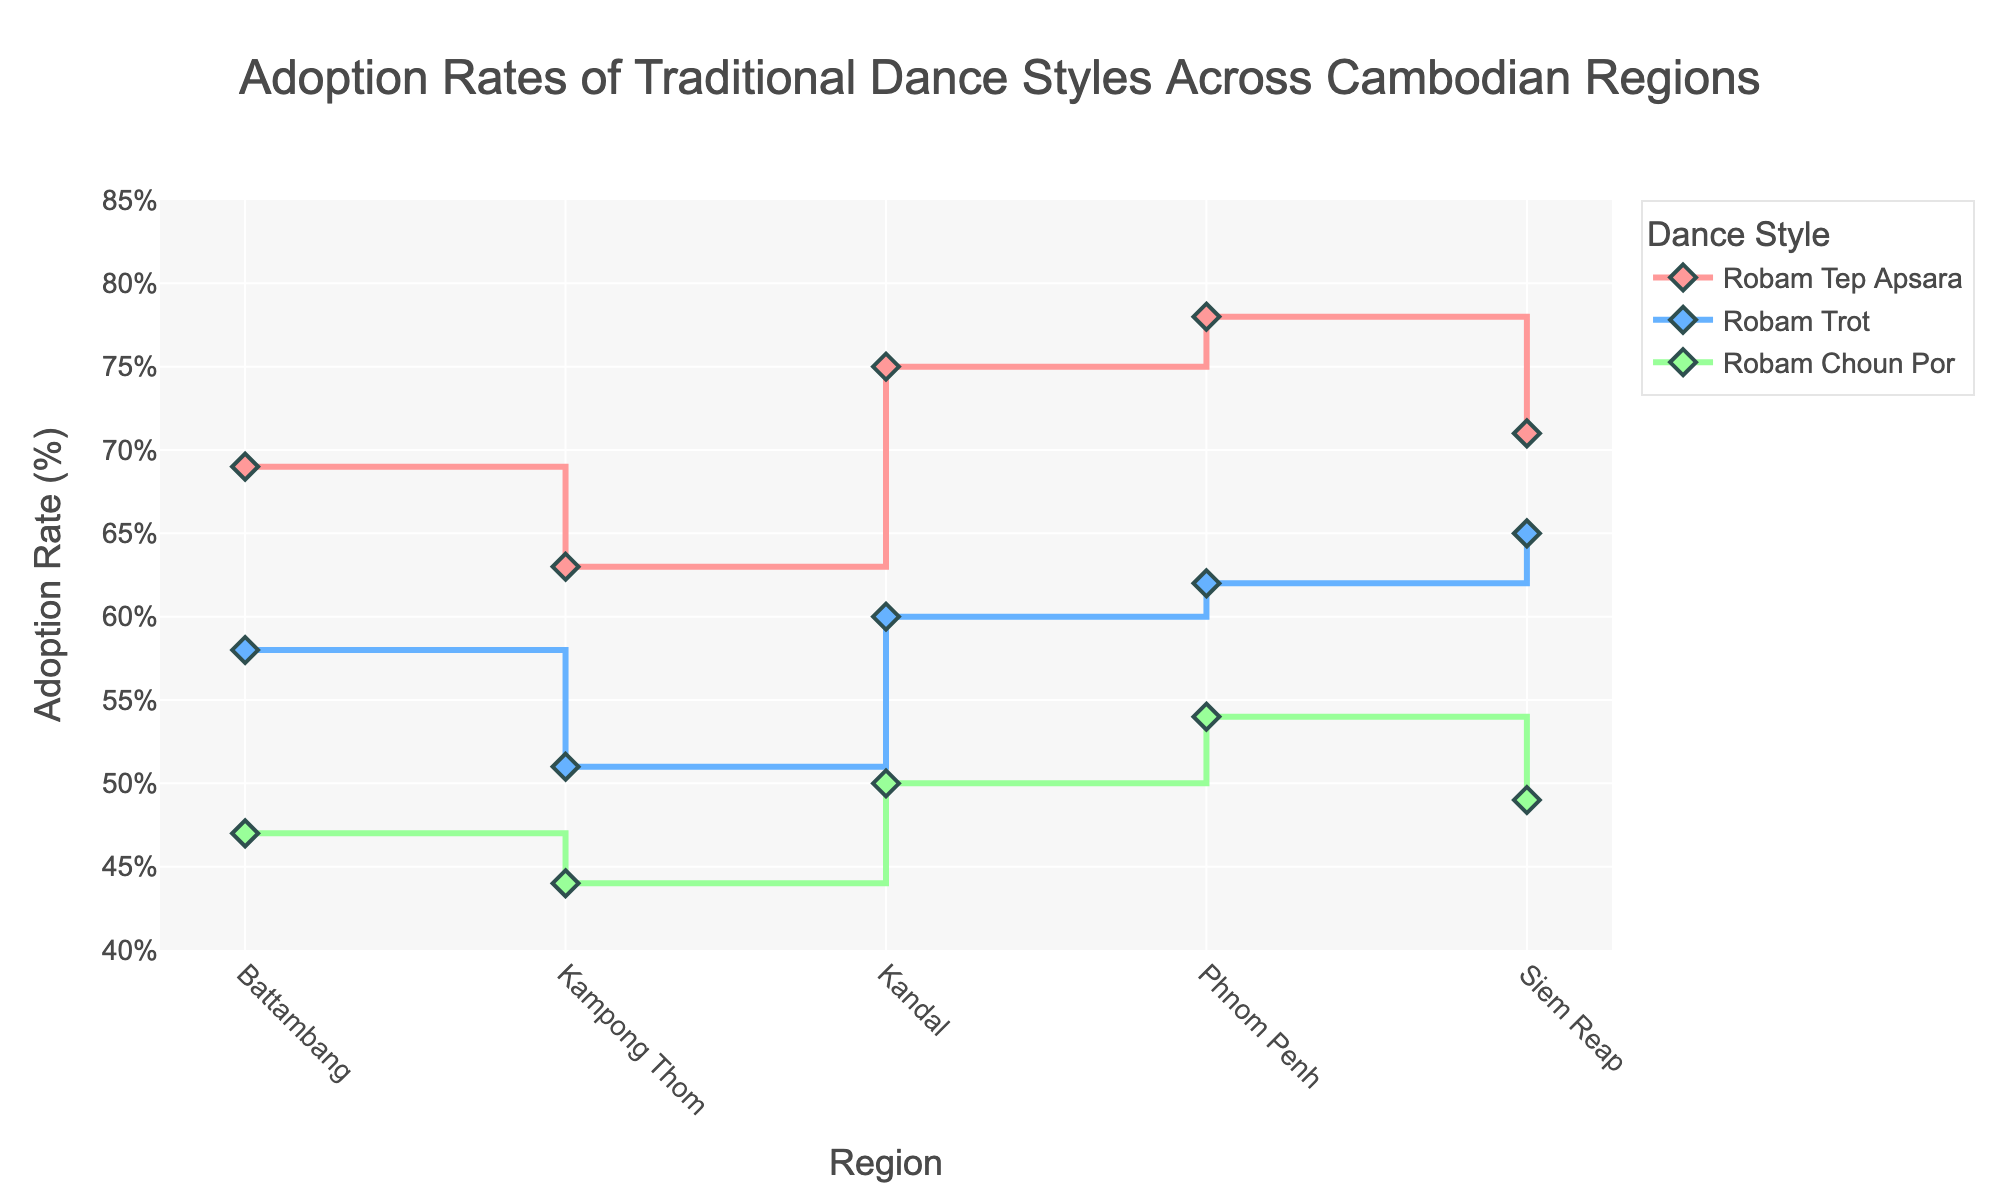What is the adoption rate of "Robam Tep Apsara" in Phnom Penh? Look for "Robam Tep Apsara" on the plot and read the adoption rate for Phnom Penh. It is represented by a pink line and diamond marker.
Answer: 78% Which region has the lowest adoption rate for "Robam Choun Por"? Identify the lowest point on the green line, which represents "Robam Choun Por", across all regions.
Answer: Kampong Thom What is the average adoption rate of "Robam Trot" across all regions? Add the adoption rates for "Robam Trot" across all regions: (62 + 65 + 58 + 51 + 60) and divide by the number of regions (5). (62+65+58+51+60)=296, so the average is 296/5=59.2
Answer: 59.2% Between Phnom Penh and Siem Reap, which region has a higher adoption rate for "Robam Choun Por"? Compare the values on the green line for Phnom Penh and Siem Reap for "Robam Choun Por". Phnom Penh is 54% and Siem Reap is 49%.
Answer: Phnom Penh How much higher is the adoption rate of "Robam Tep Apsara" compared to "Robam Choun Por" in Battambang? Subtract the adoption rate percentage of "Robam Choun Por" from that of "Robam Tep Apsara" in Battambang (69% - 47%).
Answer: 22% Which dance style has the highest adoption rate in Kandal? Look at the data points for Kandal and find the highest adoption rate among the three dance styles represented by different colored lines. Pink, blue, and green represent "Robam Tep Apsara", "Robam Trot", and "Robam Choun Por" respectively.
Answer: Robam Tep Apsara In which region is the adoption rate of "Robam Trot" closest to 60%? Look at the blue line and closest adoption rate to 60% among all regions. Kandal is exactly 60%.
Answer: Kandal What is the total adoption rate for all dance styles combined in Kampong Thom? Sum the adoption rates for Kampong Thom: (63 + 51 + 44). (63+51+44)=158
Answer: 158% Between the regions of Phnom Penh and Battambang, which one shows a greater disparity in the adoption rates among the three dance styles? Calculate the range (highest minus lowest) of adoption rates for each region. For Phnom Penh: (78 - 54) = 24. For Battambang: (69 - 47) = 22.
Answer: Phnom Penh Which dance style has the most consistent adoption rate across all regions? Check the variation of adoption rates for each dance style (represented by color-coded lines). The smallest variation indicates the most consistent adoption rate. "Robam Trot" (blue line) has rates of 62, 65, 58, 51, 60, showing the smallest range.
Answer: Robam Trot 